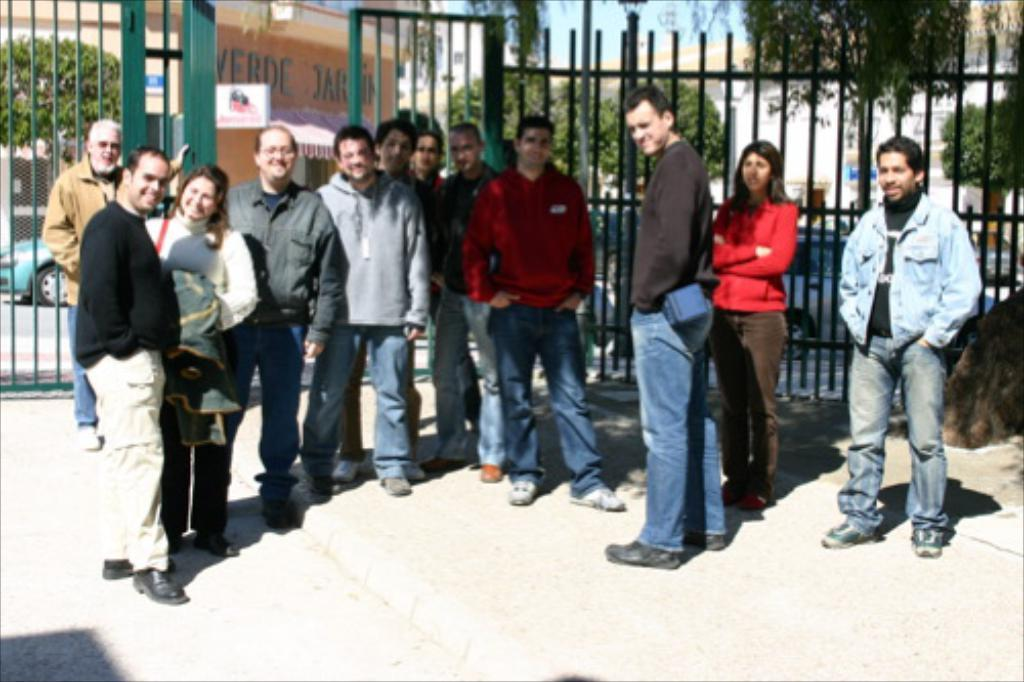How many people are in the group visible in the image? There is a group of people standing in the image, but the exact number cannot be determined from the provided facts. What type of structure can be seen in the image? There are iron grilles in the image, which might be part of a structure. What else can be seen in the image besides the group of people? There are vehicles, a house, and trees visible in the image. What type of mint is growing near the house in the image? There is no mention of mint or any plants in the image; it only includes a group of people, iron grilles, vehicles, a house, and trees. 